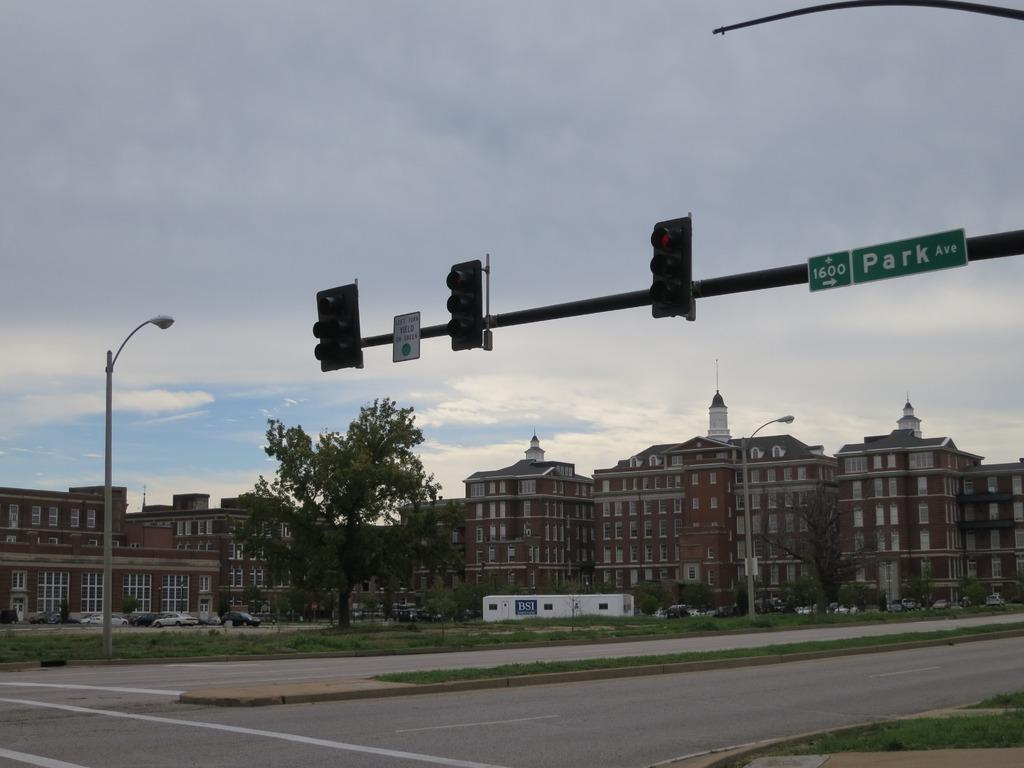<image>
Summarize the visual content of the image. A traffic light has an arrow point right to 1600 Park Av. 